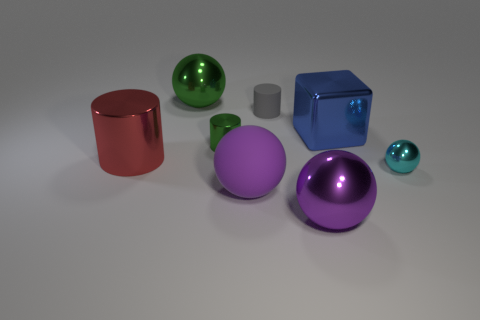Does the big matte ball have the same color as the big metallic ball in front of the green cylinder?
Your response must be concise. Yes. What number of things are metallic spheres in front of the big red object or purple objects right of the small gray rubber object?
Your answer should be compact. 2. There is a large object that is right of the purple matte object and in front of the tiny cyan shiny sphere; what color is it?
Provide a succinct answer. Purple. Are there more big objects than objects?
Provide a short and direct response. No. There is a rubber thing that is behind the big metal cylinder; does it have the same shape as the tiny green metal object?
Your response must be concise. Yes. What number of metal things are either big purple blocks or cyan spheres?
Provide a short and direct response. 1. Are there any other large green balls that have the same material as the large green sphere?
Give a very brief answer. No. What is the material of the blue thing?
Offer a very short reply. Metal. The small metal object that is right of the large shiny object in front of the tiny object to the right of the large blue object is what shape?
Give a very brief answer. Sphere. Are there more cylinders left of the small matte thing than tiny cyan balls?
Offer a terse response. Yes. 